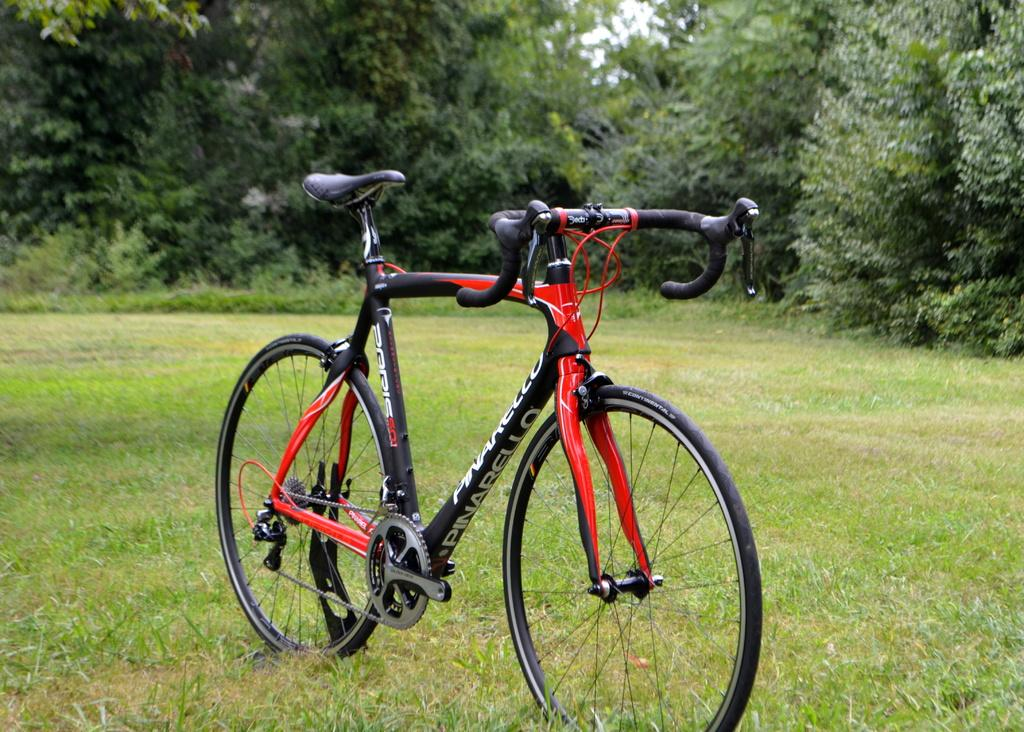What is the main object in the center of the image? There is a bicycle in the center of the image. What type of terrain is visible in the image? There is grassland in the image. What can be seen at the top side of the image? There are trees at the top side of the image. What type of pocket can be seen on the bicycle in the image? There is no pocket visible on the bicycle in the image. Can you hear a horn sound in the image? There is no sound, including a horn, present in the image. 